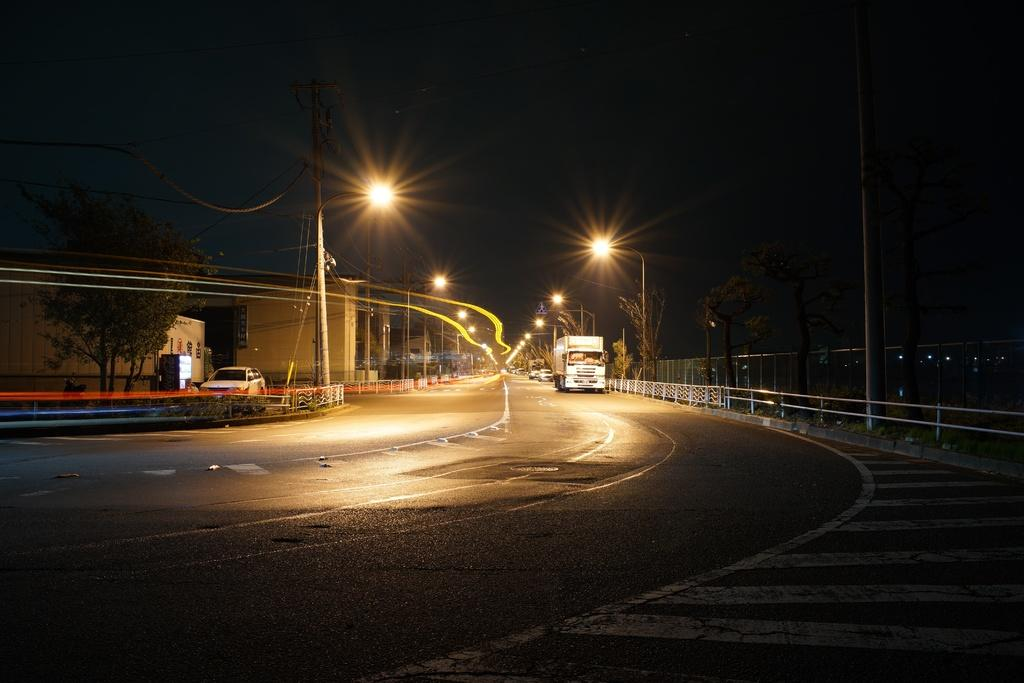What type of vehicle is located on the right side of the image? There is a truck on the right side of the image. What other vehicles can be seen in the image? There are cars in the background of the image, and there is a car moving on the left side of the image. What type of natural vegetation is visible in the image? There are trees visible in the image. How would you describe the sky in the image? The sky appears dark in the image. What type of bread is being used as a rifle in the image? There is no bread or rifle present in the image. 